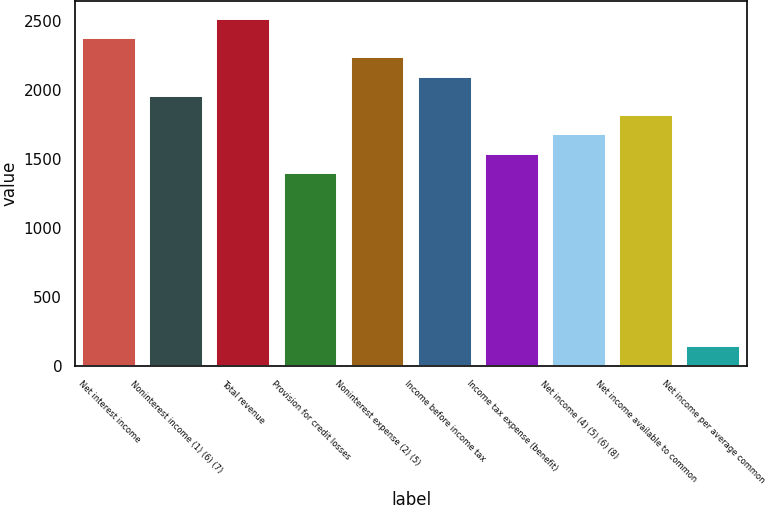<chart> <loc_0><loc_0><loc_500><loc_500><bar_chart><fcel>Net interest income<fcel>Noninterest income (1) (6) (7)<fcel>Total revenue<fcel>Provision for credit losses<fcel>Noninterest expense (2) (5)<fcel>Income before income tax<fcel>Income tax expense (benefit)<fcel>Net income (4) (5) (6) (8)<fcel>Net income available to common<fcel>Net income per average common<nl><fcel>2373.17<fcel>1954.4<fcel>2512.76<fcel>1396.04<fcel>2233.58<fcel>2093.99<fcel>1535.63<fcel>1675.22<fcel>1814.81<fcel>139.73<nl></chart> 